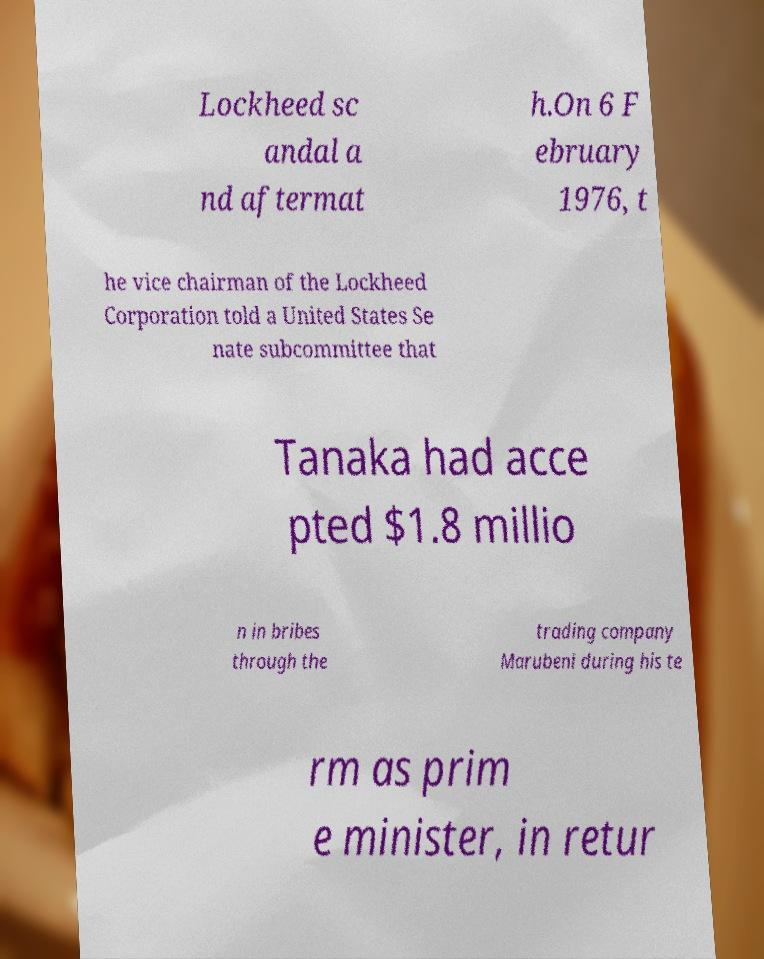There's text embedded in this image that I need extracted. Can you transcribe it verbatim? Lockheed sc andal a nd aftermat h.On 6 F ebruary 1976, t he vice chairman of the Lockheed Corporation told a United States Se nate subcommittee that Tanaka had acce pted $1.8 millio n in bribes through the trading company Marubeni during his te rm as prim e minister, in retur 